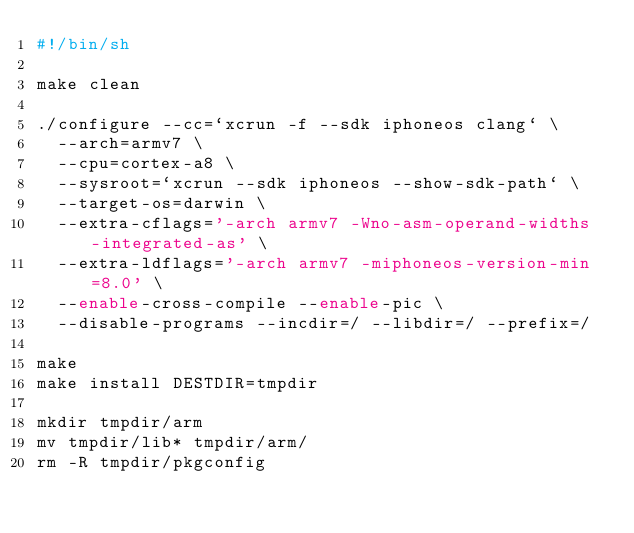<code> <loc_0><loc_0><loc_500><loc_500><_Bash_>#!/bin/sh

make clean

./configure --cc=`xcrun -f --sdk iphoneos clang` \
	--arch=armv7 \
	--cpu=cortex-a8 \
	--sysroot=`xcrun --sdk iphoneos --show-sdk-path` \
	--target-os=darwin \
	--extra-cflags='-arch armv7 -Wno-asm-operand-widths -integrated-as' \
	--extra-ldflags='-arch armv7 -miphoneos-version-min=8.0' \
	--enable-cross-compile --enable-pic \
	--disable-programs --incdir=/ --libdir=/ --prefix=/

make
make install DESTDIR=tmpdir

mkdir tmpdir/arm
mv tmpdir/lib* tmpdir/arm/
rm -R tmpdir/pkgconfig</code> 